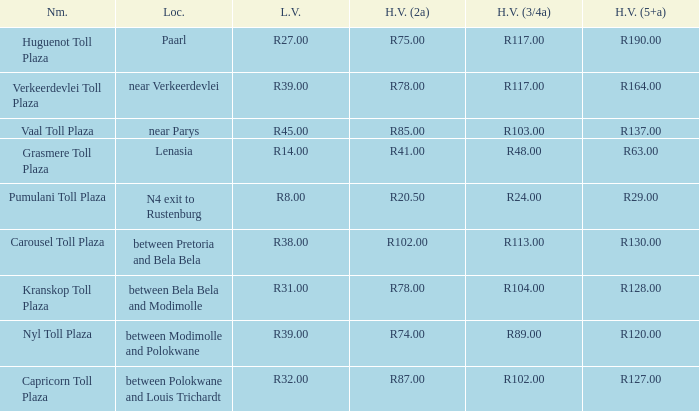50? Pumulani Toll Plaza. 